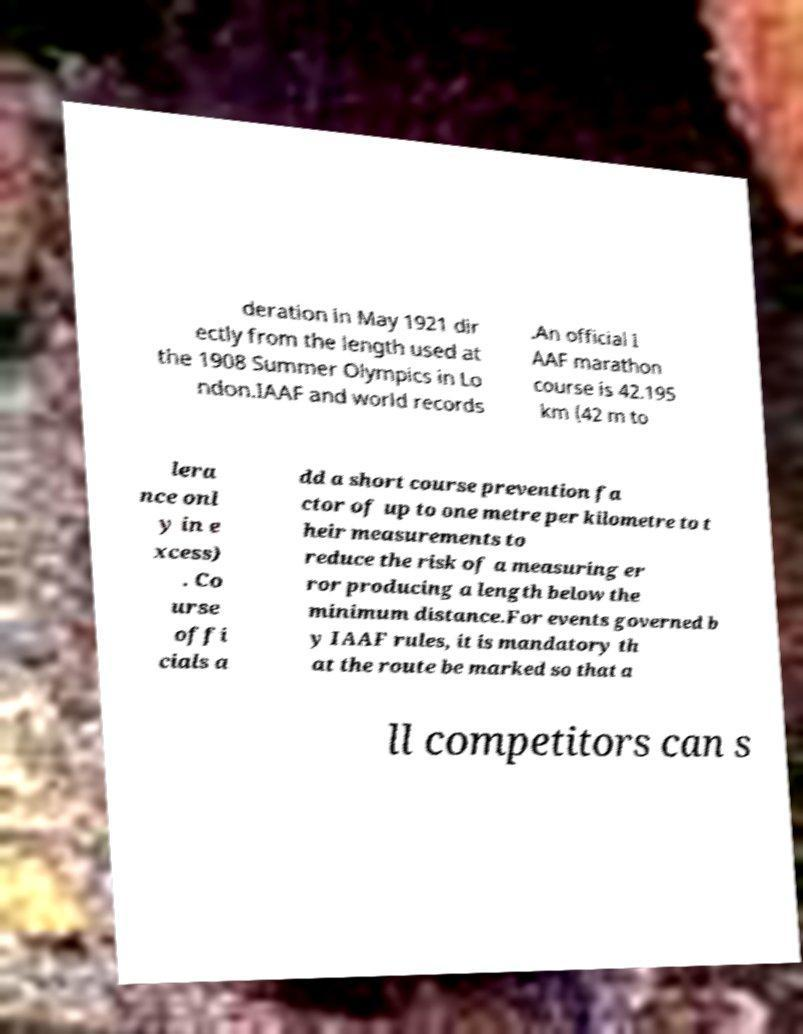I need the written content from this picture converted into text. Can you do that? deration in May 1921 dir ectly from the length used at the 1908 Summer Olympics in Lo ndon.IAAF and world records .An official I AAF marathon course is 42.195 km (42 m to lera nce onl y in e xcess) . Co urse offi cials a dd a short course prevention fa ctor of up to one metre per kilometre to t heir measurements to reduce the risk of a measuring er ror producing a length below the minimum distance.For events governed b y IAAF rules, it is mandatory th at the route be marked so that a ll competitors can s 